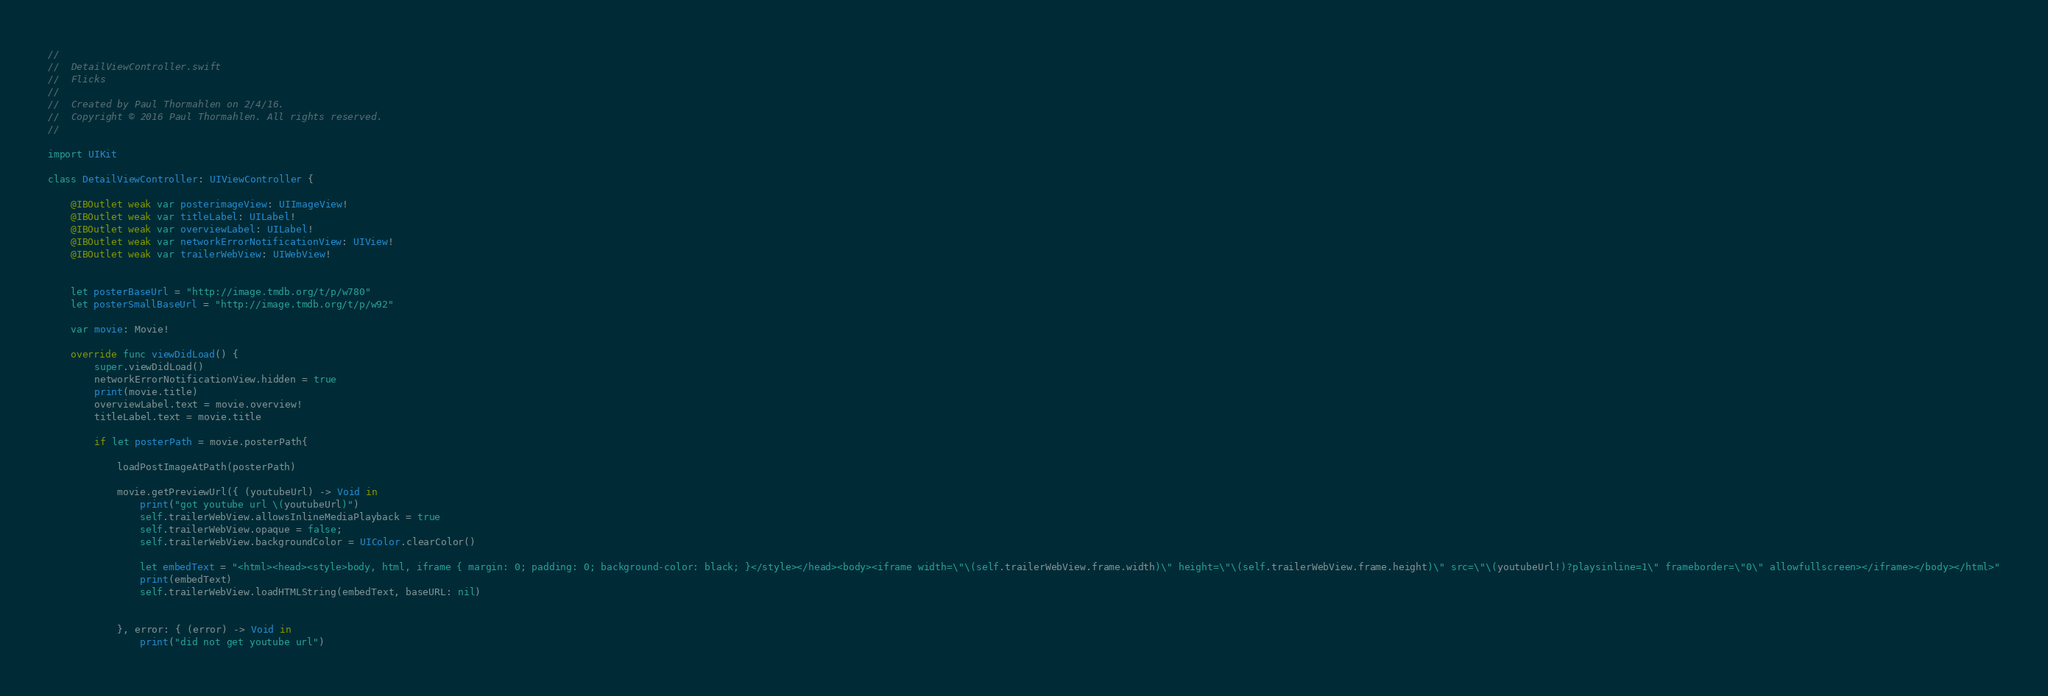Convert code to text. <code><loc_0><loc_0><loc_500><loc_500><_Swift_>//
//  DetailViewController.swift
//  Flicks
//
//  Created by Paul Thormahlen on 2/4/16.
//  Copyright © 2016 Paul Thormahlen. All rights reserved.
//

import UIKit

class DetailViewController: UIViewController {

    @IBOutlet weak var posterimageView: UIImageView!
    @IBOutlet weak var titleLabel: UILabel!
    @IBOutlet weak var overviewLabel: UILabel!
    @IBOutlet weak var networkErrorNotificationView: UIView!
    @IBOutlet weak var trailerWebView: UIWebView!
    
    
    let posterBaseUrl = "http://image.tmdb.org/t/p/w780"
    let posterSmallBaseUrl = "http://image.tmdb.org/t/p/w92"
    
    var movie: Movie!
    
    override func viewDidLoad() {
        super.viewDidLoad()
        networkErrorNotificationView.hidden = true
        print(movie.title)
        overviewLabel.text = movie.overview!
        titleLabel.text = movie.title
        
        if let posterPath = movie.posterPath{
            
            loadPostImageAtPath(posterPath)
            
            movie.getPreviewUrl({ (youtubeUrl) -> Void in
                print("got youtube url \(youtubeUrl)")
                self.trailerWebView.allowsInlineMediaPlayback = true
                self.trailerWebView.opaque = false;
                self.trailerWebView.backgroundColor = UIColor.clearColor()
                
                let embedText = "<html><head><style>body, html, iframe { margin: 0; padding: 0; background-color: black; }</style></head><body><iframe width=\"\(self.trailerWebView.frame.width)\" height=\"\(self.trailerWebView.frame.height)\" src=\"\(youtubeUrl!)?playsinline=1\" frameborder=\"0\" allowfullscreen></iframe></body></html>"
                print(embedText)
                self.trailerWebView.loadHTMLString(embedText, baseURL: nil)
                

            }, error: { (error) -> Void in
                print("did not get youtube url")</code> 